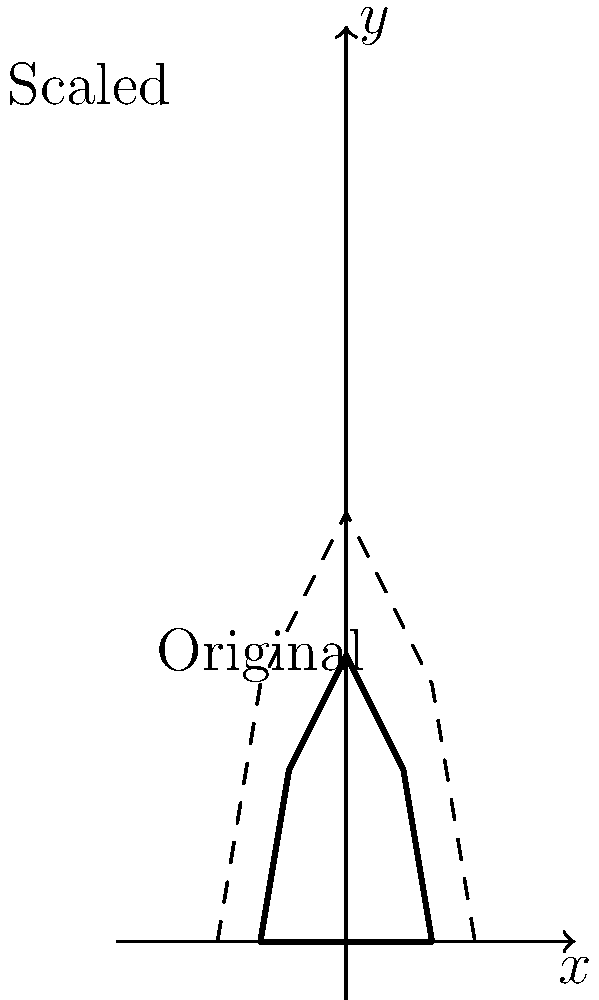As a composer working with violas, you're exploring the concept of scaling instruments for a unique performance. If you scale up the original viola shape by a factor of 1.5, what would be the new coordinates of the point that was originally at (20, 60) on the viola outline? To find the new coordinates after scaling, we follow these steps:

1) The original point is at (20, 60).

2) We are scaling by a factor of 1.5. This means we multiply both x and y coordinates by 1.5.

3) For the x-coordinate:
   $20 \times 1.5 = 30$

4) For the y-coordinate:
   $60 \times 1.5 = 90$

5) Therefore, the new point after scaling will be at (30, 90).

This scaling maintains the proportions of the original viola shape while increasing its size. As a composer, understanding this concept could help in creating pieces that explore the relationship between instrument size and sound, or in designing unique performance setups with differently scaled instruments.
Answer: (30, 90) 